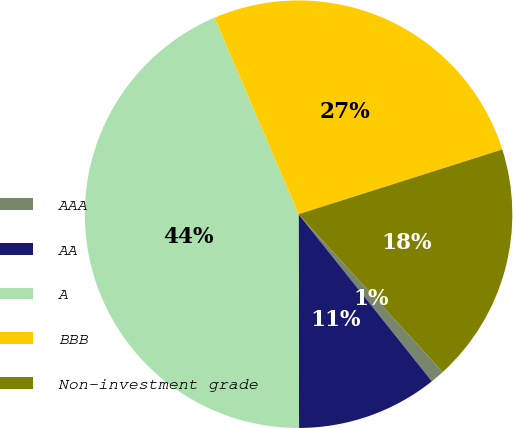Convert chart. <chart><loc_0><loc_0><loc_500><loc_500><pie_chart><fcel>AAA<fcel>AA<fcel>A<fcel>BBB<fcel>Non-investment grade<nl><fcel>1.06%<fcel>10.68%<fcel>43.6%<fcel>26.54%<fcel>18.12%<nl></chart> 